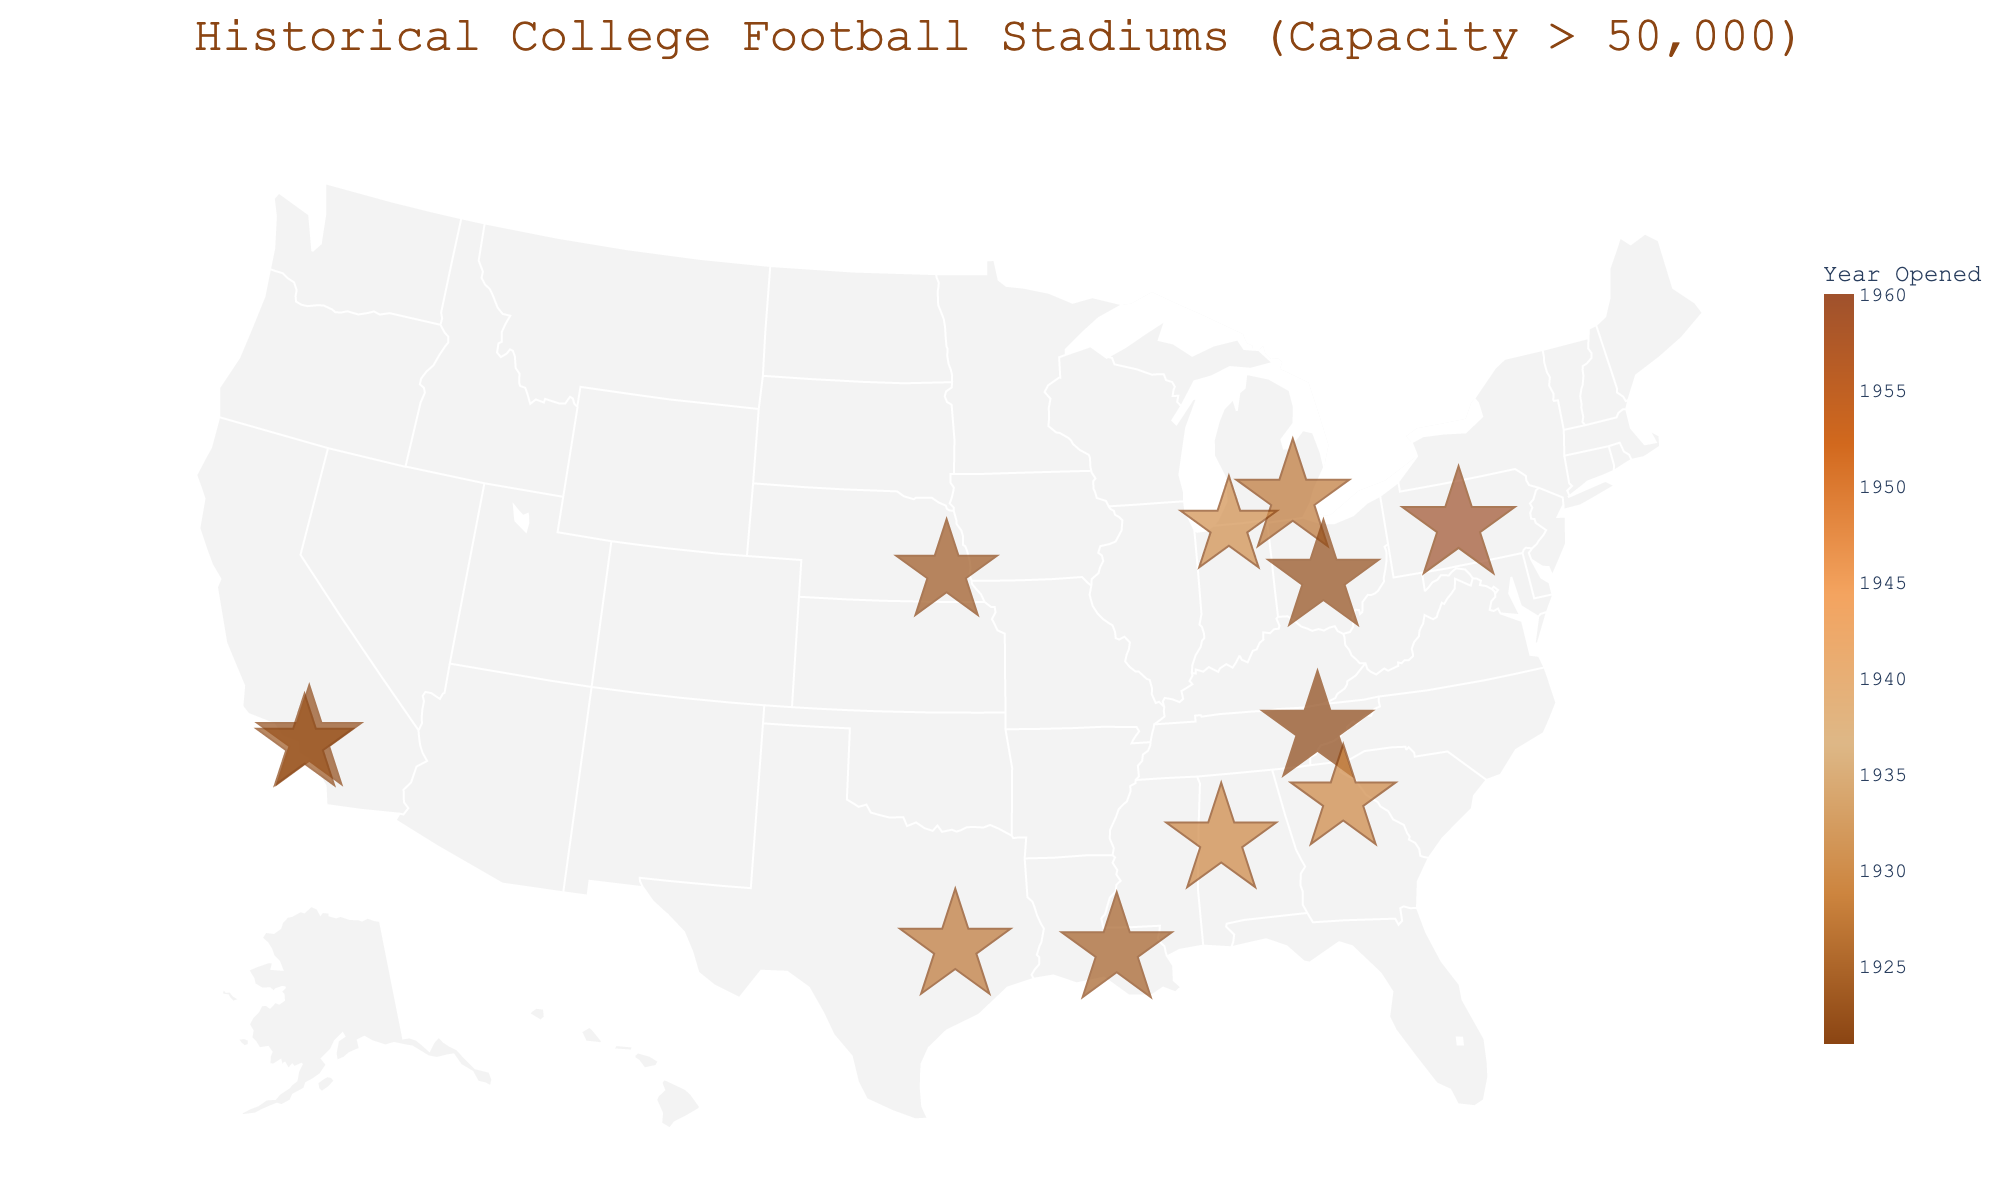How many stadiums on the map were opened before 1930? First, identify the stadiums on the map. Then, using their "Year Opened" information, count the number of stadiums with years before 1930. Analyzing these values: Neyland Stadium (1921), Ohio Stadium (1922), Rose Bowl (1922), Memorial Stadium (1923), Tiger Stadium (1924), Michigan Stadium (1927), Kyle Field (1927), Bryant-Denny Stadium (1929), and Sanford Stadium (1929), we have 9 stadiums.
Answer: 9 Which stadium has the highest capacity and where is it located? Check the hover data for each stadium on the map and find the one with the largest number in the "Capacity" field. Michigan Stadium in Ann Arbor, Michigan has the highest capacity of 107,601.
Answer: Michigan Stadium in Ann Arbor, Michigan Compare the number of stadiums in California and Texas. Which state has more? Identify the stadiums located in California and Texas by checking their "State" information. There are two stadiums in California (Rose Bowl and Los Angeles Memorial Coliseum) and one in Texas (Kyle Field). California has more stadiums.
Answer: California Which stadium is the oldest and what is its capacity? Check the "Year Opened" information for each stadium and find the one with the earliest year. Neyland Stadium, opened in 1921, is the oldest. Its capacity is 102,455.
Answer: Neyland Stadium, 102,455 What is the geographical feature of the plot labeled on the title? Look at the title of the plot to identify what geographical characteristic or element is described. The title mentions that the plot is about "Historical College Football Stadiums (Capacity > 50,000)."
Answer: Historical College Football Stadiums (Capacity > 50,000) For stadiums opened in 1922, which one has a larger capacity? Identify the stadiums opened in 1922 (Ohio Stadium and Rose Bowl) and compare their capacities. Ohio Stadium has a larger capacity of 102,780 compared to the Rose Bowl's 90,888.
Answer: Ohio Stadium What is the primary color theme of the map? Observe the map's color scheme used for different years of opening. The plot uses shades of brown and similar earth tones.
Answer: Shades of brown How many stadiums are in the eastern United States (east of the Mississippi River)? Visually identify the stadiums located east of the Mississippi River by checking their longitude coordinates. Stadiums fitting this criterion include Michigan Stadium, Ohio Stadium, Beaver Stadium, Tiger Stadium, Bryant-Denny Stadium, Neyland Stadium, and Sanford Stadium, thus totaling 7 stadiums.
Answer: 7 